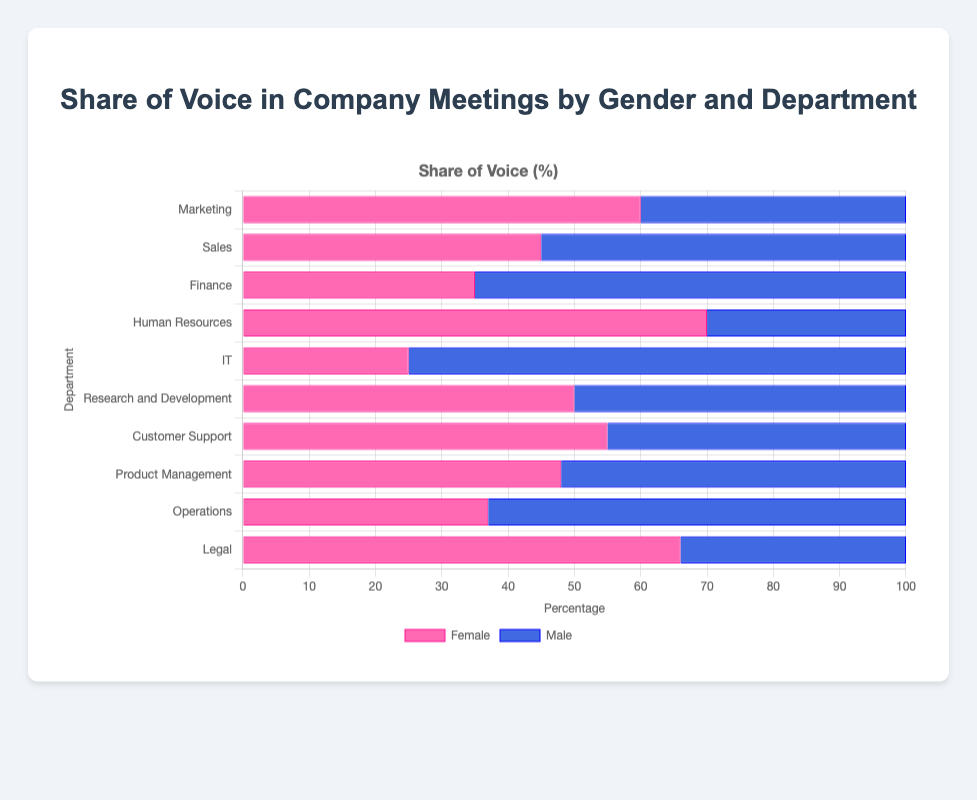Which department has the highest female share of voice? The department with the highest female share of voice can be identified by finding the department where the Female percentage is the largest. In this case, Human Resources has 70%.
Answer: Human Resources Which department shows an equal share of voice between female and male employees? An equal share of voice between female and male employees is indicated by a 50% share for both genders. Research and Development shows 50% for both female and male.
Answer: Research and Development What is the difference in the male share of voice between the IT and Marketing departments? The IT department has a male share of 75%, and Marketing has a male share of 40%. The difference is calculated as 75% - 40% = 35%.
Answer: 35% In which department do females have a larger share of voice than males? Females have a larger share of voice in departments where the Female percentage is higher than the Male percentage. These departments are Marketing, Human Resources, Customer Support, and Legal.
Answer: Marketing, Human Resources, Customer Support, Legal What is the combined female share of voice in the Sales, Finance, and Operations departments? The female share of voice in Sales is 45%, in Finance is 35%, and in Operations is 37%. The combined share is 45% + 35% + 37% = 117%.
Answer: 117% Which department has the lowest female share of voice? The department with the lowest female share of voice has the smallest Female percentage. IT has the lowest female share at 25%.
Answer: IT How much greater is the female share of voice in Legal compared to Sales? The share of voice for females in Legal is 66%, and in Sales, it is 45%. The difference is 66% - 45% = 21%.
Answer: 21% Which three departments have the highest male share of voice? The departments with the highest male share of voice have the largest Male percentages. These are IT (75%), Finance (65%), and Operations (63%).
Answer: IT, Finance, Operations What is the average female share of voice across all departments? To find the average female share of voice, sum the Female percentages and divide by the number of departments. The sum is 60 + 45 + 35 + 70 + 25 + 50 + 55 + 48 + 37 + 66 = 491. There are 10 departments, so the average is 491 / 10 = 49.1%.
Answer: 49.1% By how much does the female share of voice in Human Resources exceed that in IT? The female share of voice in Human Resources is 70%, and in IT is 25%. The difference is 70% - 25% = 45%.
Answer: 45% 